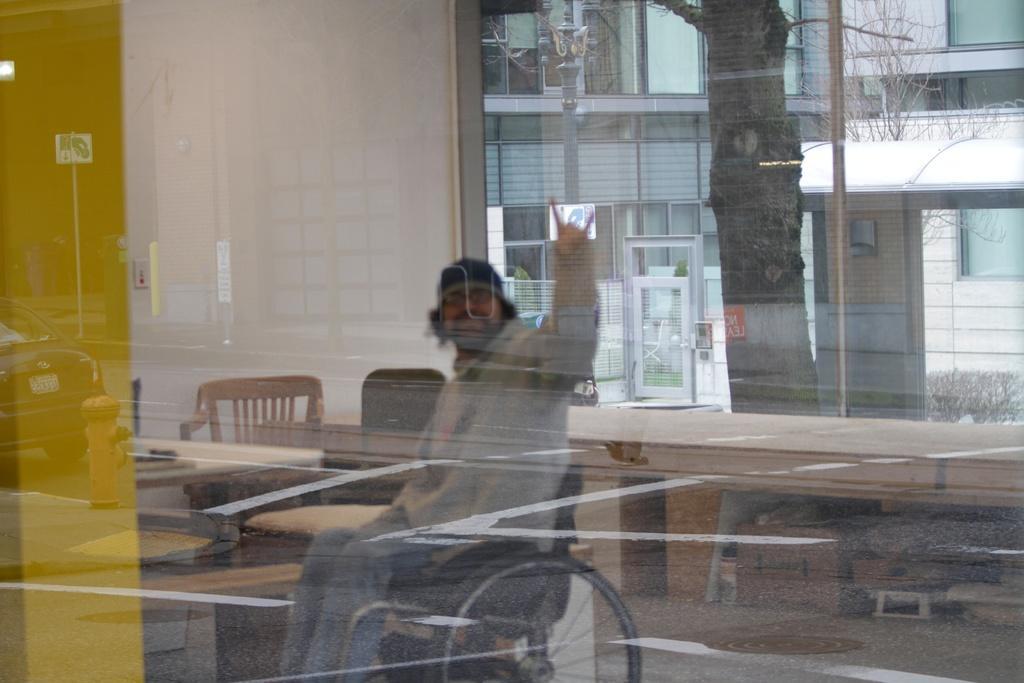Please provide a concise description of this image. In this image there is a window, inside the window there is a person wearing goggles and a cap and sitting on the wheel chair, there are chairs, few objects under the table, there is a building, tree and plants. 